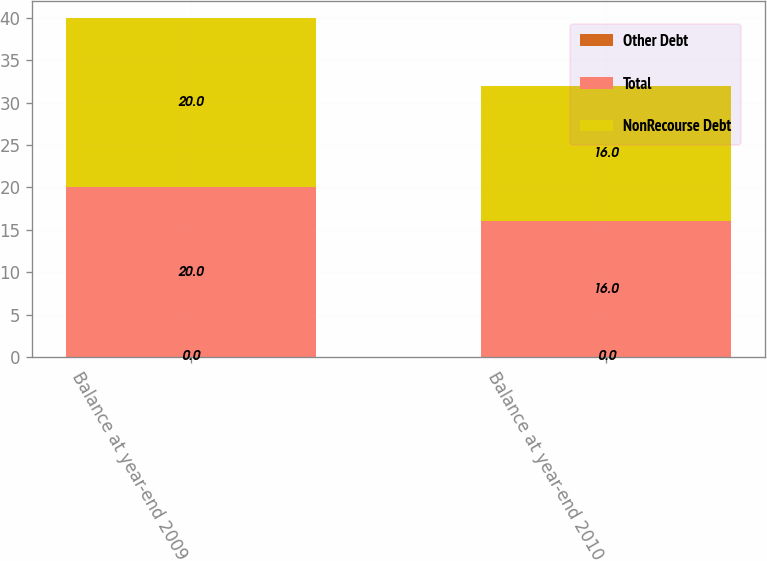Convert chart to OTSL. <chart><loc_0><loc_0><loc_500><loc_500><stacked_bar_chart><ecel><fcel>Balance at year-end 2009<fcel>Balance at year-end 2010<nl><fcel>Other Debt<fcel>0<fcel>0<nl><fcel>Total<fcel>20<fcel>16<nl><fcel>NonRecourse Debt<fcel>20<fcel>16<nl></chart> 